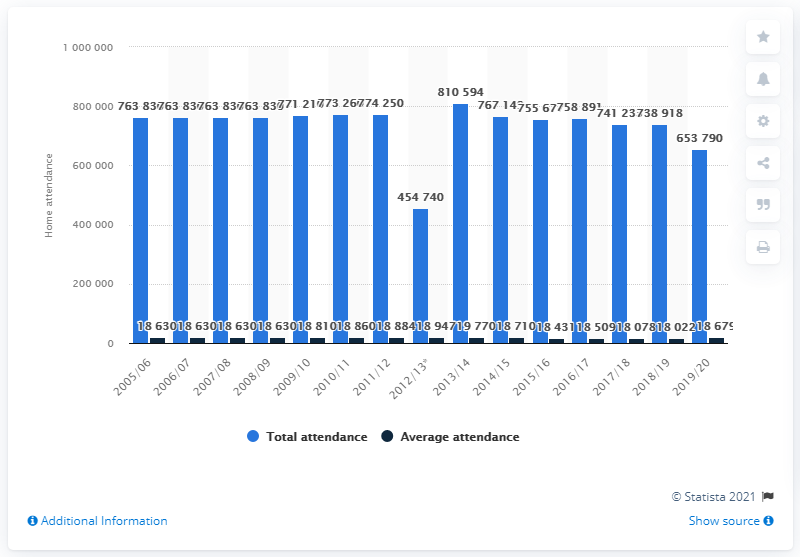Give some essential details in this illustration. During the 2005/2006 season, the Vancouver Canucks franchise played. 